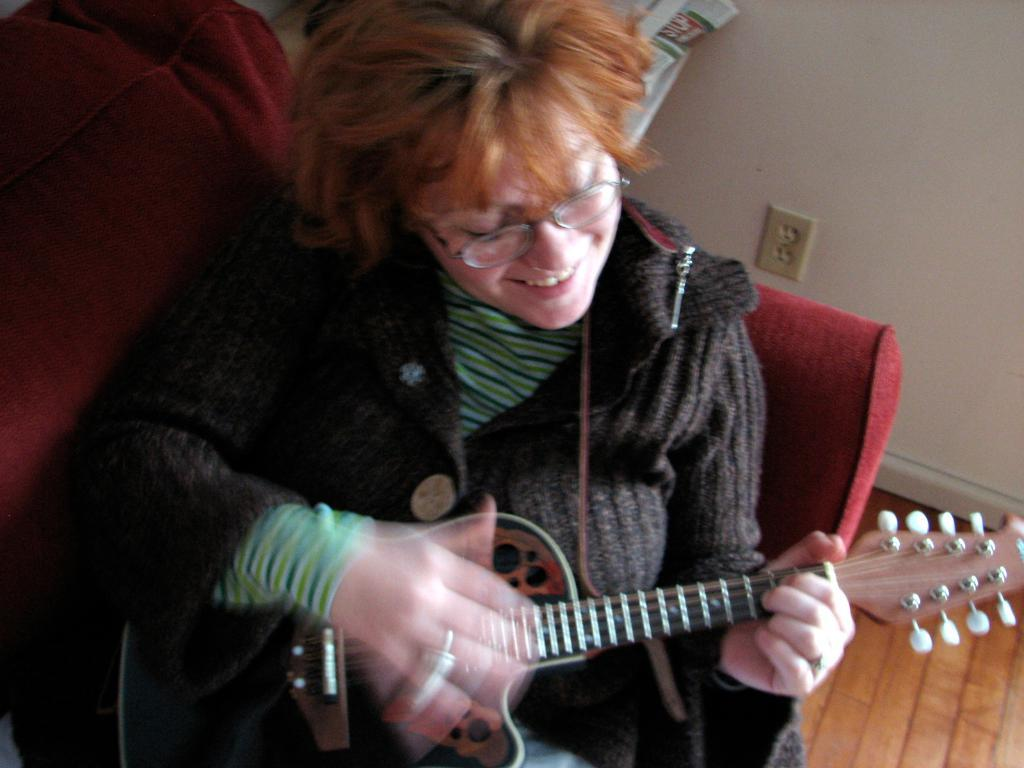Who is the main subject in the image? There is a woman in the image. What is the woman doing in the image? The woman is seated on a chair and playing a guitar. What is the woman's facial expression in the image? The woman is smiling in the image. What accessory is the woman wearing in the image? The woman is wearing spectacles in the image. What type of cakes can be seen in the image? There are no cakes present in the image; it features a woman playing a guitar. What type of school is depicted in the image? There is no school depicted in the image; it features a woman playing a guitar. 